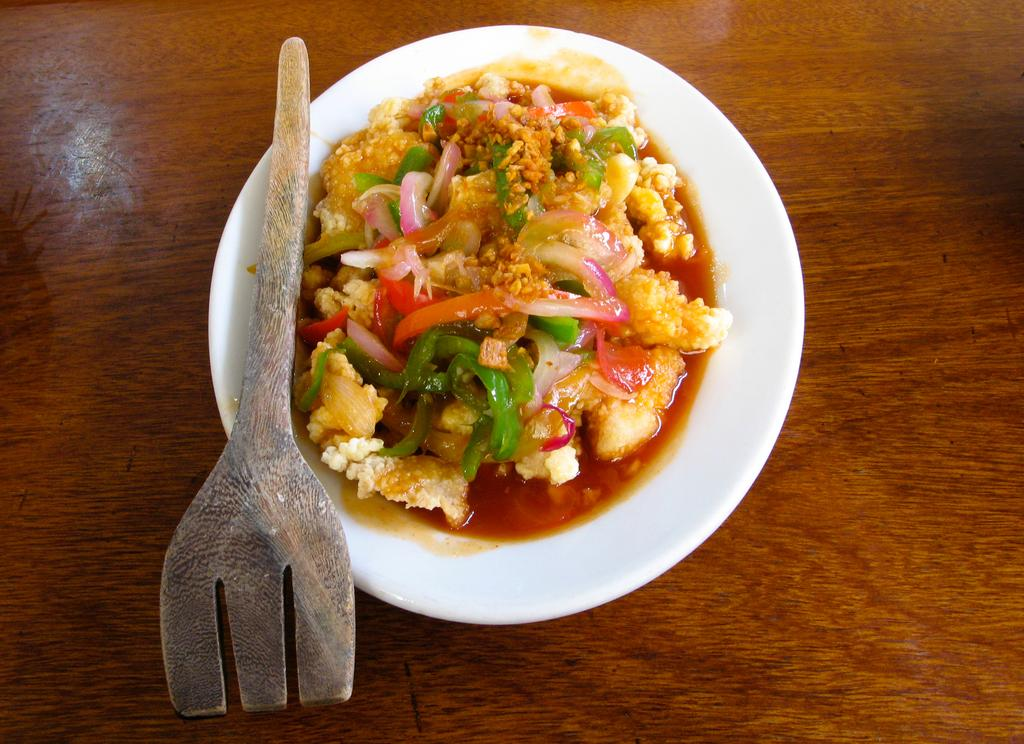What is the main object in the center of the image? There is a wooden object in the center of the image. What is placed on top of the wooden object? There is a plate on the wooden object. What is on the plate? There is an object on the wooden object. What type of food is in the plate? There is a food item in the plate. How does the ice start to melt in the image? There is no ice present in the image, so it cannot start to melt. 